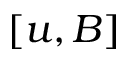Convert formula to latex. <formula><loc_0><loc_0><loc_500><loc_500>[ u , B ]</formula> 